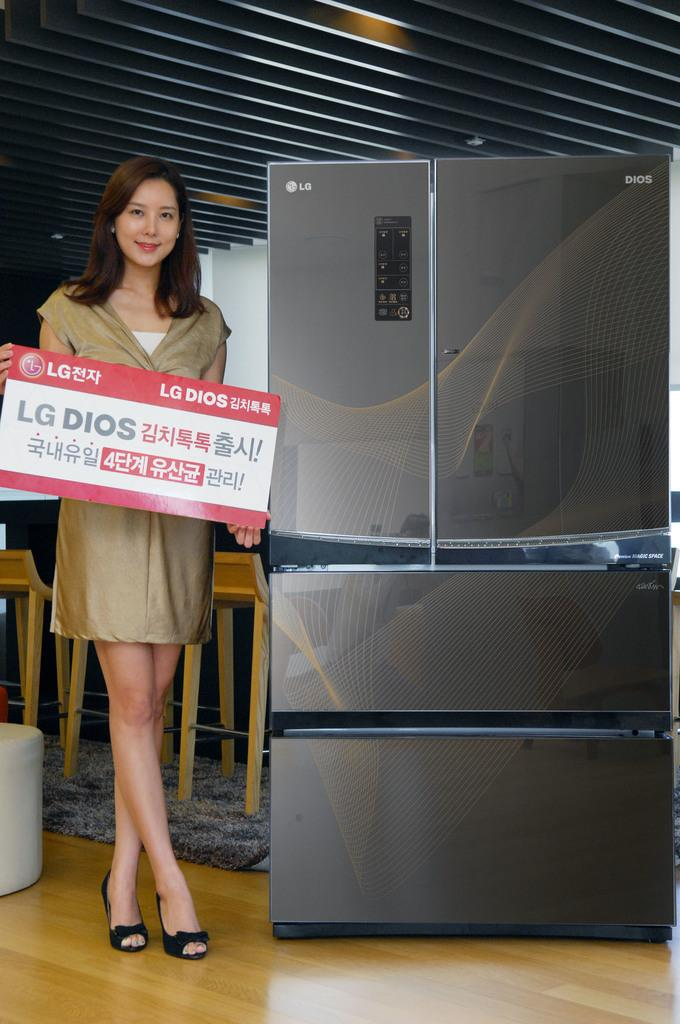<image>
Share a concise interpretation of the image provided. A woman holding a sign for LG Dios in front of a LG Dios appliance 